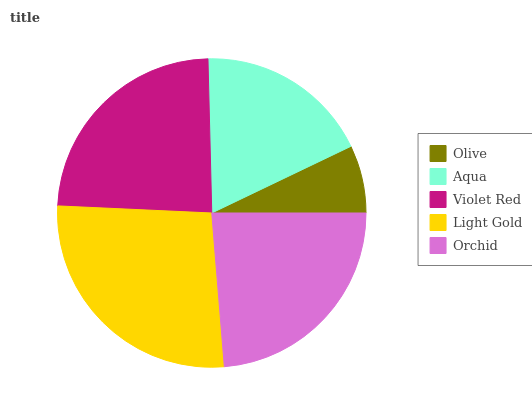Is Olive the minimum?
Answer yes or no. Yes. Is Light Gold the maximum?
Answer yes or no. Yes. Is Aqua the minimum?
Answer yes or no. No. Is Aqua the maximum?
Answer yes or no. No. Is Aqua greater than Olive?
Answer yes or no. Yes. Is Olive less than Aqua?
Answer yes or no. Yes. Is Olive greater than Aqua?
Answer yes or no. No. Is Aqua less than Olive?
Answer yes or no. No. Is Orchid the high median?
Answer yes or no. Yes. Is Orchid the low median?
Answer yes or no. Yes. Is Olive the high median?
Answer yes or no. No. Is Light Gold the low median?
Answer yes or no. No. 